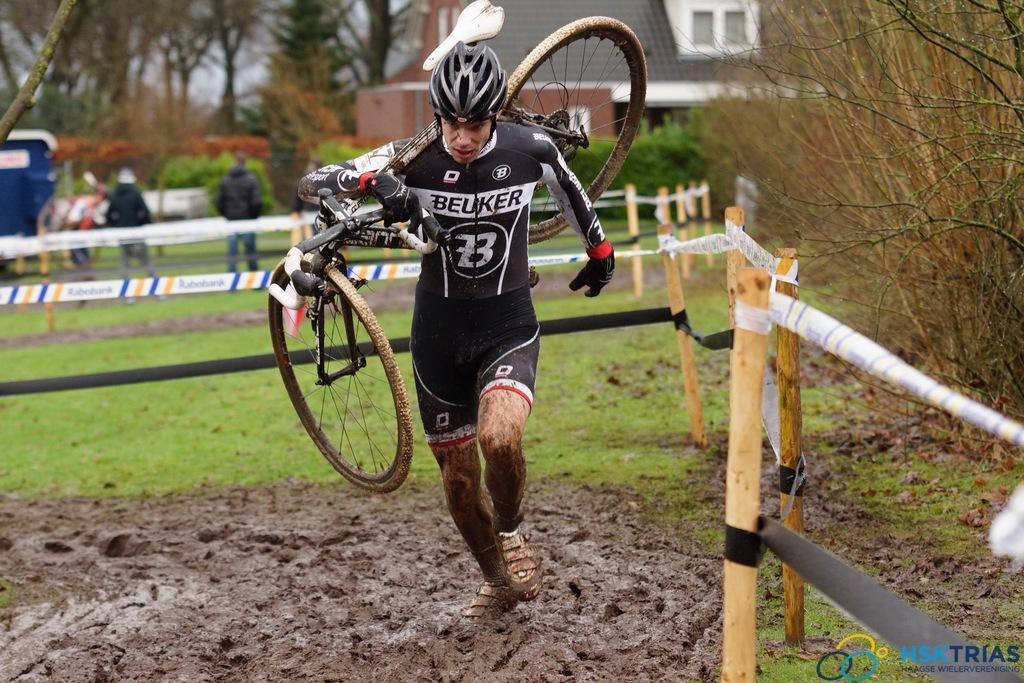Provide a one-sentence caption for the provided image. the number 23 that is on a person's outfit. 